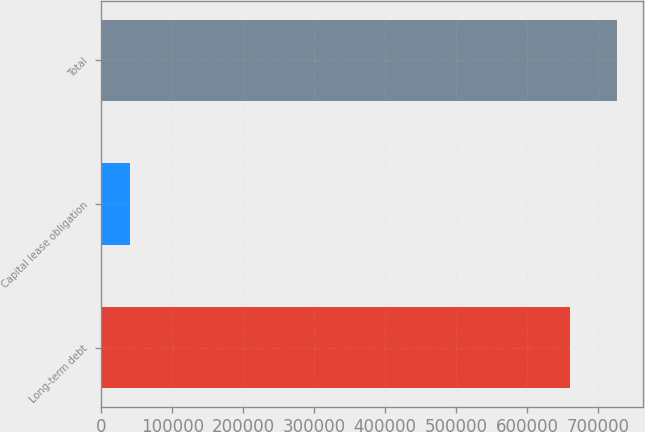Convert chart to OTSL. <chart><loc_0><loc_0><loc_500><loc_500><bar_chart><fcel>Long-term debt<fcel>Capital lease obligation<fcel>Total<nl><fcel>661023<fcel>39612<fcel>727125<nl></chart> 